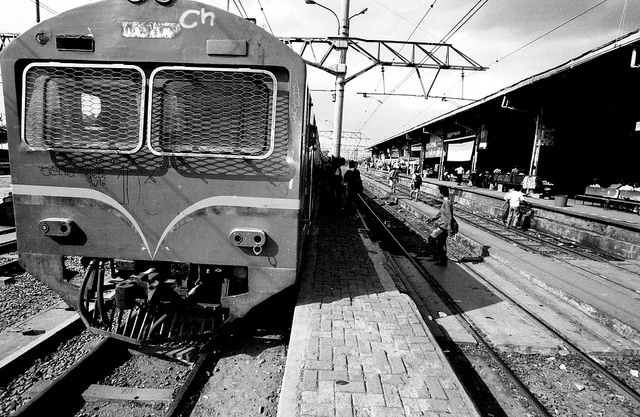Describe the objects in this image and their specific colors. I can see train in white, gray, black, and gainsboro tones, people in white, black, gray, darkgray, and lightgray tones, people in white, black, gray, darkgray, and lightgray tones, people in white, black, darkgray, gray, and lightgray tones, and people in white, black, darkgray, and gray tones in this image. 